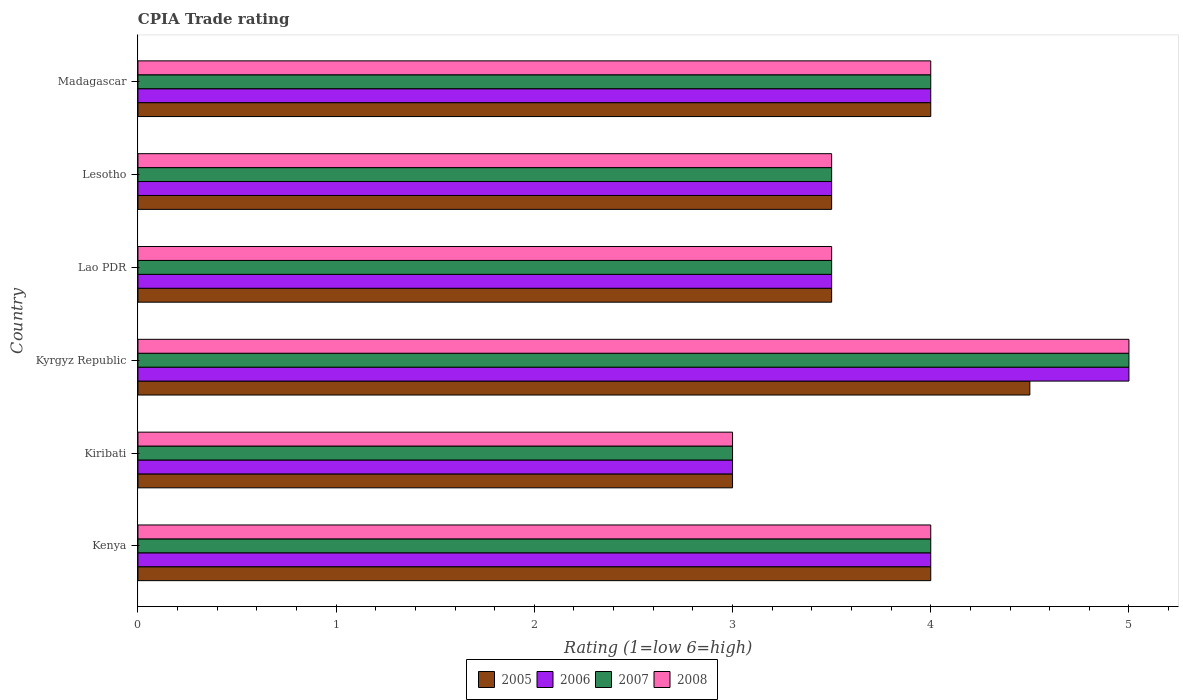How many different coloured bars are there?
Give a very brief answer. 4. Are the number of bars per tick equal to the number of legend labels?
Your response must be concise. Yes. Are the number of bars on each tick of the Y-axis equal?
Offer a very short reply. Yes. What is the label of the 2nd group of bars from the top?
Your answer should be compact. Lesotho. In how many cases, is the number of bars for a given country not equal to the number of legend labels?
Offer a very short reply. 0. What is the CPIA rating in 2006 in Lao PDR?
Your response must be concise. 3.5. In which country was the CPIA rating in 2008 maximum?
Your answer should be compact. Kyrgyz Republic. In which country was the CPIA rating in 2006 minimum?
Provide a succinct answer. Kiribati. What is the difference between the CPIA rating in 2007 in Lao PDR and the CPIA rating in 2008 in Kyrgyz Republic?
Keep it short and to the point. -1.5. What is the average CPIA rating in 2008 per country?
Provide a succinct answer. 3.83. What is the difference between the CPIA rating in 2007 and CPIA rating in 2005 in Lesotho?
Your answer should be compact. 0. What is the ratio of the CPIA rating in 2006 in Kenya to that in Lao PDR?
Provide a succinct answer. 1.14. Is the difference between the CPIA rating in 2007 in Kiribati and Lao PDR greater than the difference between the CPIA rating in 2005 in Kiribati and Lao PDR?
Offer a very short reply. No. In how many countries, is the CPIA rating in 2005 greater than the average CPIA rating in 2005 taken over all countries?
Ensure brevity in your answer.  3. Is the sum of the CPIA rating in 2007 in Kiribati and Lao PDR greater than the maximum CPIA rating in 2008 across all countries?
Provide a short and direct response. Yes. Is it the case that in every country, the sum of the CPIA rating in 2008 and CPIA rating in 2005 is greater than the sum of CPIA rating in 2007 and CPIA rating in 2006?
Make the answer very short. No. What does the 1st bar from the top in Madagascar represents?
Your answer should be compact. 2008. What does the 4th bar from the bottom in Kyrgyz Republic represents?
Provide a succinct answer. 2008. How many bars are there?
Give a very brief answer. 24. Are the values on the major ticks of X-axis written in scientific E-notation?
Keep it short and to the point. No. Does the graph contain any zero values?
Make the answer very short. No. Does the graph contain grids?
Provide a short and direct response. No. Where does the legend appear in the graph?
Your answer should be compact. Bottom center. How are the legend labels stacked?
Give a very brief answer. Horizontal. What is the title of the graph?
Offer a terse response. CPIA Trade rating. What is the label or title of the Y-axis?
Your answer should be compact. Country. What is the Rating (1=low 6=high) of 2005 in Kenya?
Offer a very short reply. 4. What is the Rating (1=low 6=high) in 2008 in Kenya?
Provide a short and direct response. 4. What is the Rating (1=low 6=high) of 2006 in Kiribati?
Provide a short and direct response. 3. What is the Rating (1=low 6=high) of 2007 in Kiribati?
Keep it short and to the point. 3. What is the Rating (1=low 6=high) in 2008 in Kiribati?
Provide a succinct answer. 3. What is the Rating (1=low 6=high) in 2008 in Kyrgyz Republic?
Give a very brief answer. 5. What is the Rating (1=low 6=high) of 2006 in Lao PDR?
Provide a short and direct response. 3.5. What is the Rating (1=low 6=high) of 2007 in Lao PDR?
Provide a succinct answer. 3.5. What is the Rating (1=low 6=high) in 2005 in Lesotho?
Offer a very short reply. 3.5. What is the Rating (1=low 6=high) in 2007 in Lesotho?
Offer a terse response. 3.5. What is the Rating (1=low 6=high) in 2007 in Madagascar?
Your response must be concise. 4. Across all countries, what is the maximum Rating (1=low 6=high) in 2005?
Give a very brief answer. 4.5. Across all countries, what is the maximum Rating (1=low 6=high) of 2006?
Provide a short and direct response. 5. Across all countries, what is the maximum Rating (1=low 6=high) in 2007?
Provide a succinct answer. 5. Across all countries, what is the minimum Rating (1=low 6=high) in 2005?
Keep it short and to the point. 3. Across all countries, what is the minimum Rating (1=low 6=high) of 2006?
Your response must be concise. 3. Across all countries, what is the minimum Rating (1=low 6=high) in 2007?
Offer a terse response. 3. Across all countries, what is the minimum Rating (1=low 6=high) in 2008?
Offer a terse response. 3. What is the difference between the Rating (1=low 6=high) of 2006 in Kenya and that in Kiribati?
Your answer should be compact. 1. What is the difference between the Rating (1=low 6=high) in 2008 in Kenya and that in Kiribati?
Your answer should be very brief. 1. What is the difference between the Rating (1=low 6=high) in 2005 in Kenya and that in Kyrgyz Republic?
Keep it short and to the point. -0.5. What is the difference between the Rating (1=low 6=high) of 2005 in Kenya and that in Lao PDR?
Your response must be concise. 0.5. What is the difference between the Rating (1=low 6=high) of 2006 in Kenya and that in Lao PDR?
Offer a terse response. 0.5. What is the difference between the Rating (1=low 6=high) of 2008 in Kenya and that in Lao PDR?
Provide a short and direct response. 0.5. What is the difference between the Rating (1=low 6=high) in 2005 in Kenya and that in Lesotho?
Provide a succinct answer. 0.5. What is the difference between the Rating (1=low 6=high) of 2006 in Kenya and that in Lesotho?
Provide a succinct answer. 0.5. What is the difference between the Rating (1=low 6=high) in 2007 in Kenya and that in Lesotho?
Make the answer very short. 0.5. What is the difference between the Rating (1=low 6=high) in 2008 in Kenya and that in Lesotho?
Offer a terse response. 0.5. What is the difference between the Rating (1=low 6=high) of 2006 in Kenya and that in Madagascar?
Your answer should be compact. 0. What is the difference between the Rating (1=low 6=high) of 2008 in Kenya and that in Madagascar?
Keep it short and to the point. 0. What is the difference between the Rating (1=low 6=high) in 2005 in Kiribati and that in Kyrgyz Republic?
Give a very brief answer. -1.5. What is the difference between the Rating (1=low 6=high) in 2007 in Kiribati and that in Kyrgyz Republic?
Keep it short and to the point. -2. What is the difference between the Rating (1=low 6=high) of 2006 in Kiribati and that in Lao PDR?
Your response must be concise. -0.5. What is the difference between the Rating (1=low 6=high) in 2007 in Kiribati and that in Lao PDR?
Provide a short and direct response. -0.5. What is the difference between the Rating (1=low 6=high) of 2008 in Kiribati and that in Lao PDR?
Ensure brevity in your answer.  -0.5. What is the difference between the Rating (1=low 6=high) of 2005 in Kiribati and that in Lesotho?
Your answer should be very brief. -0.5. What is the difference between the Rating (1=low 6=high) of 2006 in Kiribati and that in Lesotho?
Your response must be concise. -0.5. What is the difference between the Rating (1=low 6=high) in 2007 in Kiribati and that in Lesotho?
Provide a short and direct response. -0.5. What is the difference between the Rating (1=low 6=high) in 2005 in Kiribati and that in Madagascar?
Offer a very short reply. -1. What is the difference between the Rating (1=low 6=high) of 2005 in Kyrgyz Republic and that in Lao PDR?
Ensure brevity in your answer.  1. What is the difference between the Rating (1=low 6=high) in 2006 in Kyrgyz Republic and that in Lao PDR?
Provide a succinct answer. 1.5. What is the difference between the Rating (1=low 6=high) of 2006 in Kyrgyz Republic and that in Madagascar?
Provide a succinct answer. 1. What is the difference between the Rating (1=low 6=high) of 2005 in Lao PDR and that in Lesotho?
Give a very brief answer. 0. What is the difference between the Rating (1=low 6=high) of 2006 in Lao PDR and that in Lesotho?
Offer a terse response. 0. What is the difference between the Rating (1=low 6=high) of 2008 in Lao PDR and that in Lesotho?
Keep it short and to the point. 0. What is the difference between the Rating (1=low 6=high) in 2005 in Lao PDR and that in Madagascar?
Keep it short and to the point. -0.5. What is the difference between the Rating (1=low 6=high) of 2006 in Lao PDR and that in Madagascar?
Keep it short and to the point. -0.5. What is the difference between the Rating (1=low 6=high) in 2005 in Lesotho and that in Madagascar?
Provide a succinct answer. -0.5. What is the difference between the Rating (1=low 6=high) of 2006 in Lesotho and that in Madagascar?
Your answer should be very brief. -0.5. What is the difference between the Rating (1=low 6=high) in 2005 in Kenya and the Rating (1=low 6=high) in 2006 in Kiribati?
Ensure brevity in your answer.  1. What is the difference between the Rating (1=low 6=high) of 2005 in Kenya and the Rating (1=low 6=high) of 2007 in Kiribati?
Make the answer very short. 1. What is the difference between the Rating (1=low 6=high) of 2005 in Kenya and the Rating (1=low 6=high) of 2008 in Kiribati?
Ensure brevity in your answer.  1. What is the difference between the Rating (1=low 6=high) of 2005 in Kenya and the Rating (1=low 6=high) of 2008 in Kyrgyz Republic?
Keep it short and to the point. -1. What is the difference between the Rating (1=low 6=high) of 2006 in Kenya and the Rating (1=low 6=high) of 2007 in Kyrgyz Republic?
Provide a succinct answer. -1. What is the difference between the Rating (1=low 6=high) in 2007 in Kenya and the Rating (1=low 6=high) in 2008 in Kyrgyz Republic?
Your answer should be compact. -1. What is the difference between the Rating (1=low 6=high) of 2005 in Kenya and the Rating (1=low 6=high) of 2007 in Lao PDR?
Provide a succinct answer. 0.5. What is the difference between the Rating (1=low 6=high) in 2006 in Kenya and the Rating (1=low 6=high) in 2007 in Lao PDR?
Provide a succinct answer. 0.5. What is the difference between the Rating (1=low 6=high) in 2007 in Kenya and the Rating (1=low 6=high) in 2008 in Lao PDR?
Your answer should be compact. 0.5. What is the difference between the Rating (1=low 6=high) of 2005 in Kenya and the Rating (1=low 6=high) of 2006 in Lesotho?
Offer a terse response. 0.5. What is the difference between the Rating (1=low 6=high) of 2005 in Kenya and the Rating (1=low 6=high) of 2007 in Lesotho?
Ensure brevity in your answer.  0.5. What is the difference between the Rating (1=low 6=high) of 2005 in Kenya and the Rating (1=low 6=high) of 2008 in Lesotho?
Keep it short and to the point. 0.5. What is the difference between the Rating (1=low 6=high) in 2006 in Kenya and the Rating (1=low 6=high) in 2008 in Lesotho?
Offer a terse response. 0.5. What is the difference between the Rating (1=low 6=high) of 2005 in Kenya and the Rating (1=low 6=high) of 2006 in Madagascar?
Offer a terse response. 0. What is the difference between the Rating (1=low 6=high) of 2005 in Kiribati and the Rating (1=low 6=high) of 2007 in Kyrgyz Republic?
Give a very brief answer. -2. What is the difference between the Rating (1=low 6=high) of 2006 in Kiribati and the Rating (1=low 6=high) of 2007 in Kyrgyz Republic?
Give a very brief answer. -2. What is the difference between the Rating (1=low 6=high) of 2006 in Kiribati and the Rating (1=low 6=high) of 2008 in Kyrgyz Republic?
Offer a terse response. -2. What is the difference between the Rating (1=low 6=high) of 2007 in Kiribati and the Rating (1=low 6=high) of 2008 in Kyrgyz Republic?
Your response must be concise. -2. What is the difference between the Rating (1=low 6=high) of 2006 in Kiribati and the Rating (1=low 6=high) of 2007 in Lao PDR?
Keep it short and to the point. -0.5. What is the difference between the Rating (1=low 6=high) of 2005 in Kiribati and the Rating (1=low 6=high) of 2006 in Lesotho?
Offer a terse response. -0.5. What is the difference between the Rating (1=low 6=high) in 2005 in Kiribati and the Rating (1=low 6=high) in 2007 in Lesotho?
Your answer should be compact. -0.5. What is the difference between the Rating (1=low 6=high) of 2005 in Kiribati and the Rating (1=low 6=high) of 2008 in Lesotho?
Ensure brevity in your answer.  -0.5. What is the difference between the Rating (1=low 6=high) of 2006 in Kiribati and the Rating (1=low 6=high) of 2008 in Lesotho?
Keep it short and to the point. -0.5. What is the difference between the Rating (1=low 6=high) of 2007 in Kiribati and the Rating (1=low 6=high) of 2008 in Lesotho?
Provide a succinct answer. -0.5. What is the difference between the Rating (1=low 6=high) of 2005 in Kiribati and the Rating (1=low 6=high) of 2006 in Madagascar?
Give a very brief answer. -1. What is the difference between the Rating (1=low 6=high) in 2005 in Kiribati and the Rating (1=low 6=high) in 2007 in Madagascar?
Provide a succinct answer. -1. What is the difference between the Rating (1=low 6=high) in 2006 in Kiribati and the Rating (1=low 6=high) in 2007 in Madagascar?
Make the answer very short. -1. What is the difference between the Rating (1=low 6=high) in 2006 in Kiribati and the Rating (1=low 6=high) in 2008 in Madagascar?
Provide a succinct answer. -1. What is the difference between the Rating (1=low 6=high) in 2007 in Kiribati and the Rating (1=low 6=high) in 2008 in Madagascar?
Your response must be concise. -1. What is the difference between the Rating (1=low 6=high) of 2005 in Kyrgyz Republic and the Rating (1=low 6=high) of 2006 in Lao PDR?
Your answer should be compact. 1. What is the difference between the Rating (1=low 6=high) in 2005 in Kyrgyz Republic and the Rating (1=low 6=high) in 2006 in Lesotho?
Your answer should be compact. 1. What is the difference between the Rating (1=low 6=high) in 2005 in Kyrgyz Republic and the Rating (1=low 6=high) in 2007 in Lesotho?
Give a very brief answer. 1. What is the difference between the Rating (1=low 6=high) of 2006 in Kyrgyz Republic and the Rating (1=low 6=high) of 2007 in Lesotho?
Keep it short and to the point. 1.5. What is the difference between the Rating (1=low 6=high) of 2006 in Kyrgyz Republic and the Rating (1=low 6=high) of 2008 in Lesotho?
Make the answer very short. 1.5. What is the difference between the Rating (1=low 6=high) in 2007 in Kyrgyz Republic and the Rating (1=low 6=high) in 2008 in Lesotho?
Your response must be concise. 1.5. What is the difference between the Rating (1=low 6=high) in 2006 in Kyrgyz Republic and the Rating (1=low 6=high) in 2008 in Madagascar?
Your response must be concise. 1. What is the difference between the Rating (1=low 6=high) in 2005 in Lao PDR and the Rating (1=low 6=high) in 2006 in Lesotho?
Your answer should be compact. 0. What is the difference between the Rating (1=low 6=high) of 2005 in Lao PDR and the Rating (1=low 6=high) of 2007 in Lesotho?
Provide a short and direct response. 0. What is the difference between the Rating (1=low 6=high) in 2005 in Lao PDR and the Rating (1=low 6=high) in 2008 in Lesotho?
Your answer should be compact. 0. What is the difference between the Rating (1=low 6=high) in 2007 in Lao PDR and the Rating (1=low 6=high) in 2008 in Lesotho?
Your response must be concise. 0. What is the difference between the Rating (1=low 6=high) in 2005 in Lao PDR and the Rating (1=low 6=high) in 2006 in Madagascar?
Your response must be concise. -0.5. What is the difference between the Rating (1=low 6=high) in 2005 in Lao PDR and the Rating (1=low 6=high) in 2007 in Madagascar?
Keep it short and to the point. -0.5. What is the difference between the Rating (1=low 6=high) in 2006 in Lao PDR and the Rating (1=low 6=high) in 2007 in Madagascar?
Keep it short and to the point. -0.5. What is the difference between the Rating (1=low 6=high) of 2006 in Lao PDR and the Rating (1=low 6=high) of 2008 in Madagascar?
Provide a succinct answer. -0.5. What is the difference between the Rating (1=low 6=high) of 2007 in Lao PDR and the Rating (1=low 6=high) of 2008 in Madagascar?
Keep it short and to the point. -0.5. What is the difference between the Rating (1=low 6=high) of 2006 in Lesotho and the Rating (1=low 6=high) of 2007 in Madagascar?
Your answer should be compact. -0.5. What is the average Rating (1=low 6=high) of 2005 per country?
Make the answer very short. 3.75. What is the average Rating (1=low 6=high) of 2006 per country?
Ensure brevity in your answer.  3.83. What is the average Rating (1=low 6=high) of 2007 per country?
Give a very brief answer. 3.83. What is the average Rating (1=low 6=high) of 2008 per country?
Your answer should be compact. 3.83. What is the difference between the Rating (1=low 6=high) of 2005 and Rating (1=low 6=high) of 2007 in Kenya?
Provide a short and direct response. 0. What is the difference between the Rating (1=low 6=high) in 2006 and Rating (1=low 6=high) in 2007 in Kenya?
Offer a terse response. 0. What is the difference between the Rating (1=low 6=high) of 2006 and Rating (1=low 6=high) of 2008 in Kenya?
Ensure brevity in your answer.  0. What is the difference between the Rating (1=low 6=high) in 2007 and Rating (1=low 6=high) in 2008 in Kenya?
Provide a succinct answer. 0. What is the difference between the Rating (1=low 6=high) of 2005 and Rating (1=low 6=high) of 2006 in Kiribati?
Keep it short and to the point. 0. What is the difference between the Rating (1=low 6=high) of 2006 and Rating (1=low 6=high) of 2007 in Kiribati?
Give a very brief answer. 0. What is the difference between the Rating (1=low 6=high) of 2005 and Rating (1=low 6=high) of 2006 in Kyrgyz Republic?
Your response must be concise. -0.5. What is the difference between the Rating (1=low 6=high) of 2005 and Rating (1=low 6=high) of 2007 in Kyrgyz Republic?
Offer a very short reply. -0.5. What is the difference between the Rating (1=low 6=high) in 2006 and Rating (1=low 6=high) in 2008 in Kyrgyz Republic?
Ensure brevity in your answer.  0. What is the difference between the Rating (1=low 6=high) in 2007 and Rating (1=low 6=high) in 2008 in Kyrgyz Republic?
Keep it short and to the point. 0. What is the difference between the Rating (1=low 6=high) of 2006 and Rating (1=low 6=high) of 2007 in Lao PDR?
Provide a short and direct response. 0. What is the difference between the Rating (1=low 6=high) in 2006 and Rating (1=low 6=high) in 2008 in Lao PDR?
Your response must be concise. 0. What is the difference between the Rating (1=low 6=high) of 2007 and Rating (1=low 6=high) of 2008 in Lao PDR?
Give a very brief answer. 0. What is the difference between the Rating (1=low 6=high) in 2005 and Rating (1=low 6=high) in 2008 in Lesotho?
Keep it short and to the point. 0. What is the difference between the Rating (1=low 6=high) of 2006 and Rating (1=low 6=high) of 2007 in Lesotho?
Keep it short and to the point. 0. What is the difference between the Rating (1=low 6=high) of 2006 and Rating (1=low 6=high) of 2008 in Lesotho?
Your answer should be compact. 0. What is the difference between the Rating (1=low 6=high) in 2007 and Rating (1=low 6=high) in 2008 in Lesotho?
Give a very brief answer. 0. What is the difference between the Rating (1=low 6=high) of 2005 and Rating (1=low 6=high) of 2006 in Madagascar?
Keep it short and to the point. 0. What is the difference between the Rating (1=low 6=high) of 2005 and Rating (1=low 6=high) of 2007 in Madagascar?
Make the answer very short. 0. What is the difference between the Rating (1=low 6=high) of 2005 and Rating (1=low 6=high) of 2008 in Madagascar?
Provide a succinct answer. 0. What is the difference between the Rating (1=low 6=high) in 2006 and Rating (1=low 6=high) in 2008 in Madagascar?
Make the answer very short. 0. What is the difference between the Rating (1=low 6=high) of 2007 and Rating (1=low 6=high) of 2008 in Madagascar?
Provide a short and direct response. 0. What is the ratio of the Rating (1=low 6=high) in 2007 in Kenya to that in Kiribati?
Provide a succinct answer. 1.33. What is the ratio of the Rating (1=low 6=high) in 2008 in Kenya to that in Kiribati?
Offer a very short reply. 1.33. What is the ratio of the Rating (1=low 6=high) in 2005 in Kenya to that in Kyrgyz Republic?
Your response must be concise. 0.89. What is the ratio of the Rating (1=low 6=high) in 2006 in Kenya to that in Kyrgyz Republic?
Provide a short and direct response. 0.8. What is the ratio of the Rating (1=low 6=high) in 2008 in Kenya to that in Kyrgyz Republic?
Your answer should be compact. 0.8. What is the ratio of the Rating (1=low 6=high) in 2005 in Kenya to that in Lao PDR?
Give a very brief answer. 1.14. What is the ratio of the Rating (1=low 6=high) in 2008 in Kenya to that in Lao PDR?
Provide a short and direct response. 1.14. What is the ratio of the Rating (1=low 6=high) of 2005 in Kenya to that in Lesotho?
Your response must be concise. 1.14. What is the ratio of the Rating (1=low 6=high) in 2006 in Kenya to that in Lesotho?
Your answer should be compact. 1.14. What is the ratio of the Rating (1=low 6=high) of 2006 in Kenya to that in Madagascar?
Your answer should be very brief. 1. What is the ratio of the Rating (1=low 6=high) in 2008 in Kenya to that in Madagascar?
Give a very brief answer. 1. What is the ratio of the Rating (1=low 6=high) in 2005 in Kiribati to that in Kyrgyz Republic?
Offer a terse response. 0.67. What is the ratio of the Rating (1=low 6=high) in 2006 in Kiribati to that in Kyrgyz Republic?
Offer a terse response. 0.6. What is the ratio of the Rating (1=low 6=high) in 2007 in Kiribati to that in Kyrgyz Republic?
Provide a short and direct response. 0.6. What is the ratio of the Rating (1=low 6=high) in 2008 in Kiribati to that in Lao PDR?
Your response must be concise. 0.86. What is the ratio of the Rating (1=low 6=high) of 2005 in Kiribati to that in Lesotho?
Your answer should be very brief. 0.86. What is the ratio of the Rating (1=low 6=high) in 2007 in Kiribati to that in Madagascar?
Your response must be concise. 0.75. What is the ratio of the Rating (1=low 6=high) in 2008 in Kiribati to that in Madagascar?
Offer a very short reply. 0.75. What is the ratio of the Rating (1=low 6=high) in 2005 in Kyrgyz Republic to that in Lao PDR?
Make the answer very short. 1.29. What is the ratio of the Rating (1=low 6=high) of 2006 in Kyrgyz Republic to that in Lao PDR?
Make the answer very short. 1.43. What is the ratio of the Rating (1=low 6=high) of 2007 in Kyrgyz Republic to that in Lao PDR?
Your answer should be very brief. 1.43. What is the ratio of the Rating (1=low 6=high) in 2008 in Kyrgyz Republic to that in Lao PDR?
Keep it short and to the point. 1.43. What is the ratio of the Rating (1=low 6=high) in 2005 in Kyrgyz Republic to that in Lesotho?
Give a very brief answer. 1.29. What is the ratio of the Rating (1=low 6=high) in 2006 in Kyrgyz Republic to that in Lesotho?
Keep it short and to the point. 1.43. What is the ratio of the Rating (1=low 6=high) of 2007 in Kyrgyz Republic to that in Lesotho?
Keep it short and to the point. 1.43. What is the ratio of the Rating (1=low 6=high) of 2008 in Kyrgyz Republic to that in Lesotho?
Your response must be concise. 1.43. What is the ratio of the Rating (1=low 6=high) of 2008 in Kyrgyz Republic to that in Madagascar?
Your answer should be compact. 1.25. What is the ratio of the Rating (1=low 6=high) in 2005 in Lao PDR to that in Lesotho?
Give a very brief answer. 1. What is the ratio of the Rating (1=low 6=high) in 2005 in Lao PDR to that in Madagascar?
Give a very brief answer. 0.88. What is the ratio of the Rating (1=low 6=high) in 2006 in Lao PDR to that in Madagascar?
Keep it short and to the point. 0.88. What is the ratio of the Rating (1=low 6=high) of 2007 in Lao PDR to that in Madagascar?
Give a very brief answer. 0.88. What is the difference between the highest and the second highest Rating (1=low 6=high) in 2005?
Your answer should be very brief. 0.5. What is the difference between the highest and the second highest Rating (1=low 6=high) in 2006?
Your answer should be compact. 1. What is the difference between the highest and the second highest Rating (1=low 6=high) in 2007?
Your answer should be very brief. 1. What is the difference between the highest and the lowest Rating (1=low 6=high) of 2005?
Make the answer very short. 1.5. What is the difference between the highest and the lowest Rating (1=low 6=high) in 2006?
Offer a very short reply. 2. What is the difference between the highest and the lowest Rating (1=low 6=high) in 2007?
Ensure brevity in your answer.  2. 